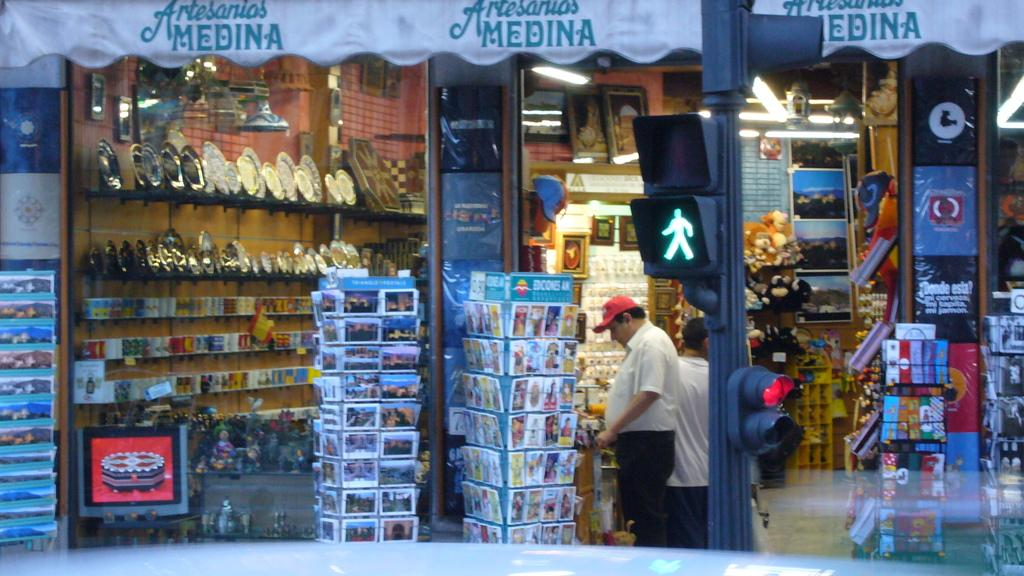<image>
Give a short and clear explanation of the subsequent image. A few shoppers, one wearing a red hat, at Artesanios Medina 